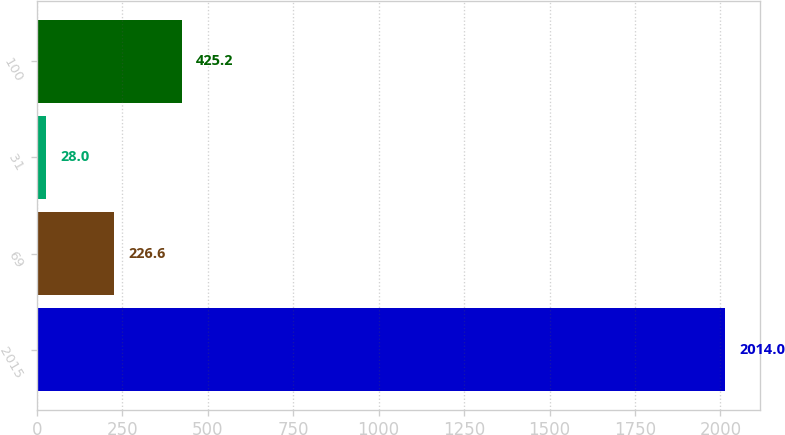Convert chart to OTSL. <chart><loc_0><loc_0><loc_500><loc_500><bar_chart><fcel>2015<fcel>69<fcel>31<fcel>100<nl><fcel>2014<fcel>226.6<fcel>28<fcel>425.2<nl></chart> 